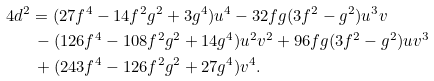Convert formula to latex. <formula><loc_0><loc_0><loc_500><loc_500>4 d ^ { 2 } & = ( 2 7 f ^ { 4 } - 1 4 f ^ { 2 } g ^ { 2 } + 3 g ^ { 4 } ) u ^ { 4 } - 3 2 f g ( 3 f ^ { 2 } - g ^ { 2 } ) u ^ { 3 } v \\ & \, - ( 1 2 6 f ^ { 4 } - 1 0 8 f ^ { 2 } g ^ { 2 } + 1 4 g ^ { 4 } ) u ^ { 2 } v ^ { 2 } + 9 6 f g ( 3 f ^ { 2 } - g ^ { 2 } ) u v ^ { 3 } \\ & \, + ( 2 4 3 f ^ { 4 } - 1 2 6 f ^ { 2 } g ^ { 2 } + 2 7 g ^ { 4 } ) v ^ { 4 } .</formula> 